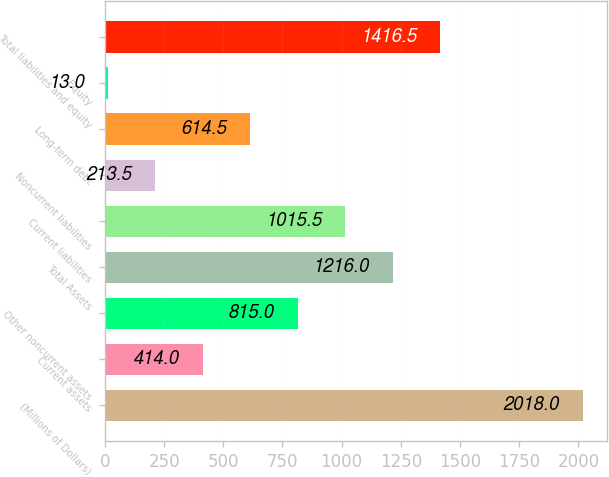<chart> <loc_0><loc_0><loc_500><loc_500><bar_chart><fcel>(Millions of Dollars)<fcel>Current assets<fcel>Other noncurrent assets<fcel>Total Assets<fcel>Current liabilities<fcel>Noncurrent liabilities<fcel>Long-term debt<fcel>Equity<fcel>Total liabilities and equity<nl><fcel>2018<fcel>414<fcel>815<fcel>1216<fcel>1015.5<fcel>213.5<fcel>614.5<fcel>13<fcel>1416.5<nl></chart> 